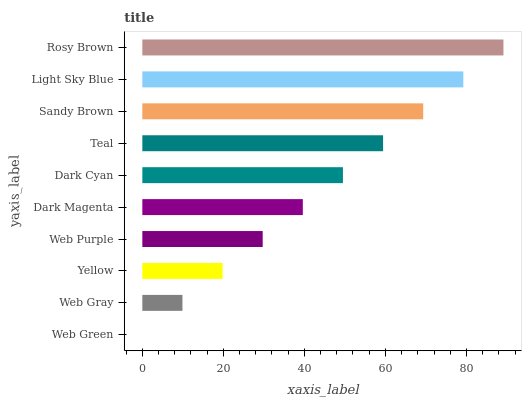Is Web Green the minimum?
Answer yes or no. Yes. Is Rosy Brown the maximum?
Answer yes or no. Yes. Is Web Gray the minimum?
Answer yes or no. No. Is Web Gray the maximum?
Answer yes or no. No. Is Web Gray greater than Web Green?
Answer yes or no. Yes. Is Web Green less than Web Gray?
Answer yes or no. Yes. Is Web Green greater than Web Gray?
Answer yes or no. No. Is Web Gray less than Web Green?
Answer yes or no. No. Is Dark Cyan the high median?
Answer yes or no. Yes. Is Dark Magenta the low median?
Answer yes or no. Yes. Is Web Green the high median?
Answer yes or no. No. Is Dark Cyan the low median?
Answer yes or no. No. 